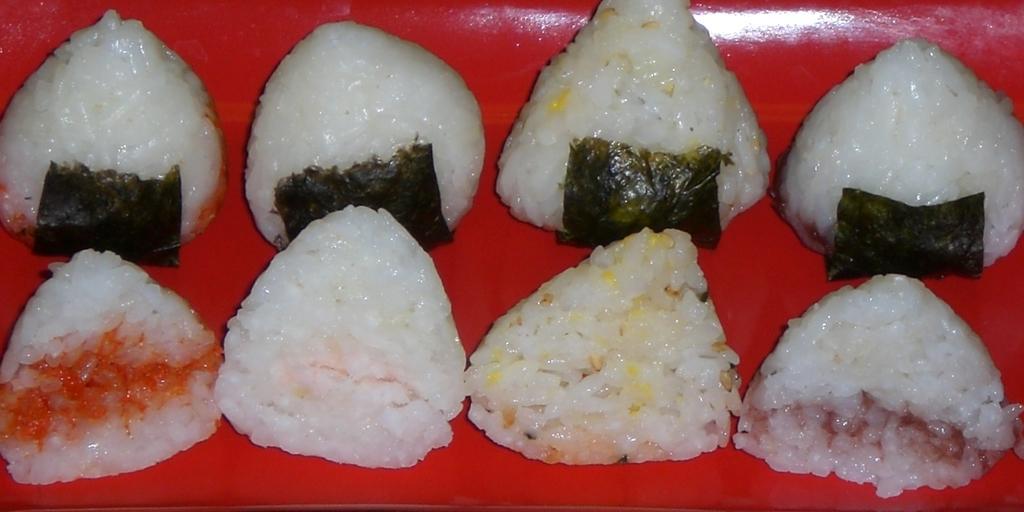Can you describe this image briefly? In this image, I can see eight pieces of rice cakes, which are placed on the plate. This plate is red in color. 